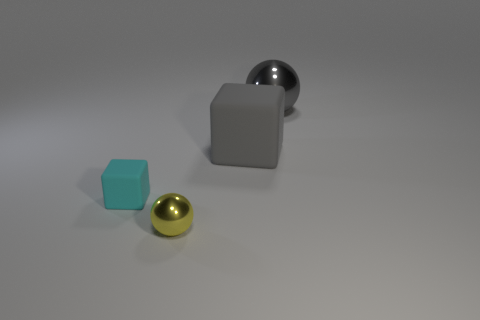Is the color of the large metal object the same as the big matte block?
Provide a succinct answer. Yes. There is a shiny object that is on the right side of the ball on the left side of the shiny object right of the small yellow ball; what color is it?
Give a very brief answer. Gray. What number of objects are objects on the left side of the yellow metallic ball or tiny objects that are behind the tiny yellow sphere?
Keep it short and to the point. 1. How many other things are there of the same color as the small metal object?
Offer a very short reply. 0. There is a matte object that is right of the small cyan matte object; is its shape the same as the cyan matte thing?
Your answer should be compact. Yes. Is the number of large shiny things that are in front of the small sphere less than the number of gray metal objects?
Keep it short and to the point. Yes. Are there any other cubes that have the same material as the big block?
Give a very brief answer. Yes. There is a cube that is the same size as the gray shiny object; what is its material?
Offer a terse response. Rubber. Is the number of gray cubes that are behind the large block less than the number of metal things behind the big shiny sphere?
Give a very brief answer. No. What is the shape of the object that is right of the yellow metallic sphere and in front of the large gray shiny ball?
Provide a short and direct response. Cube. 